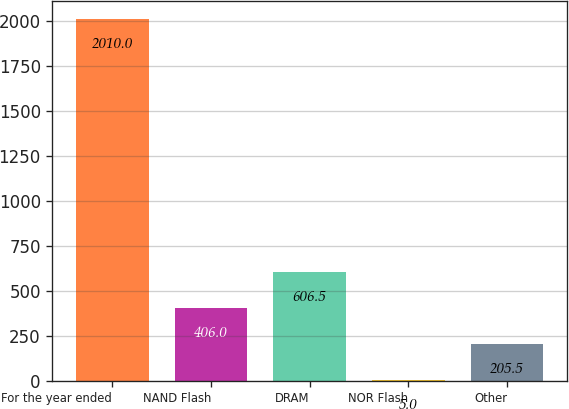Convert chart to OTSL. <chart><loc_0><loc_0><loc_500><loc_500><bar_chart><fcel>For the year ended<fcel>NAND Flash<fcel>DRAM<fcel>NOR Flash<fcel>Other<nl><fcel>2010<fcel>406<fcel>606.5<fcel>5<fcel>205.5<nl></chart> 